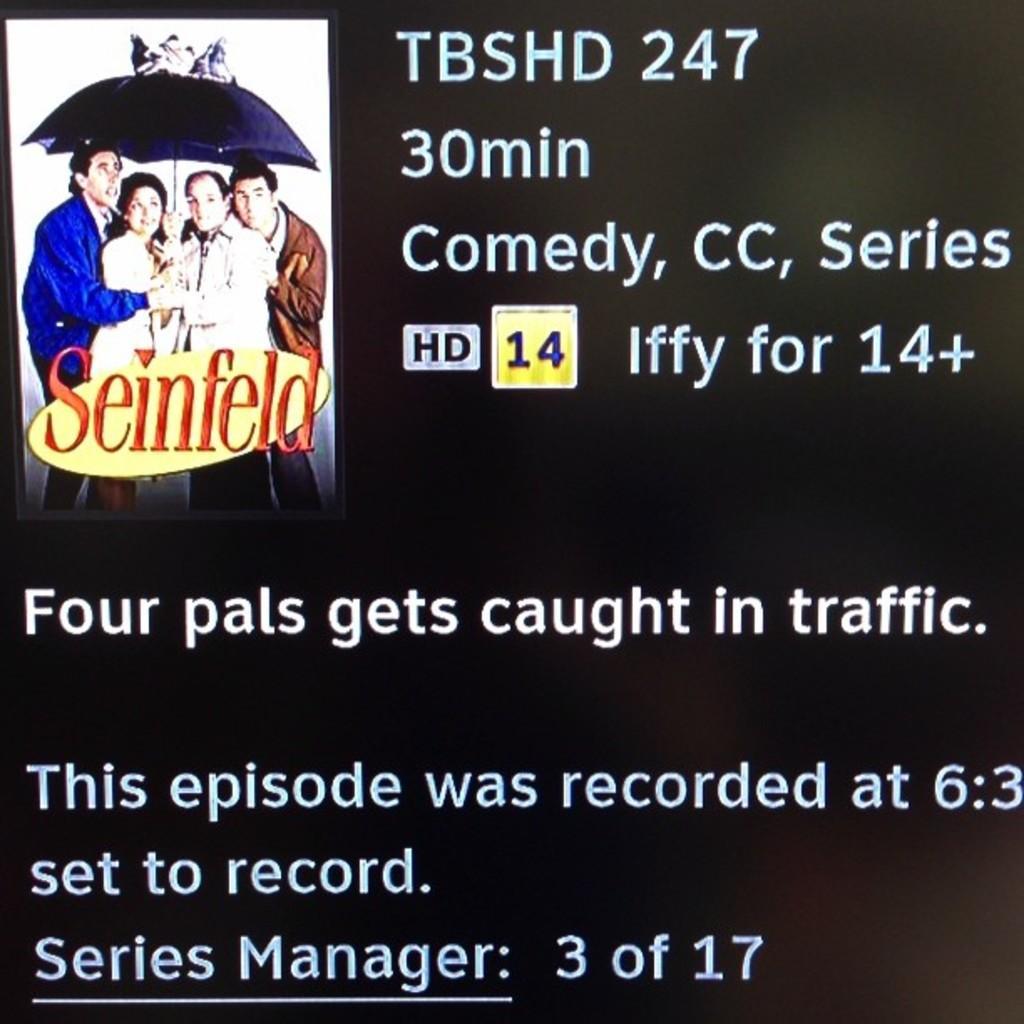What is present in the image that features images of people? There is a poster in the image that contains images of four people. What else can be found on the poster besides the images of people? There is text on the poster. How many spots can be seen on the hen in the image? There is no hen present in the image; it only features a poster with images of people and text. 